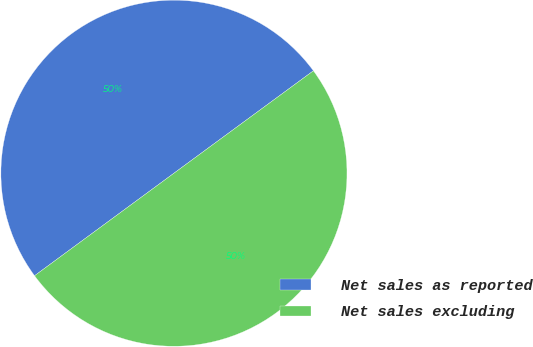Convert chart to OTSL. <chart><loc_0><loc_0><loc_500><loc_500><pie_chart><fcel>Net sales as reported<fcel>Net sales excluding<nl><fcel>50.01%<fcel>49.99%<nl></chart> 